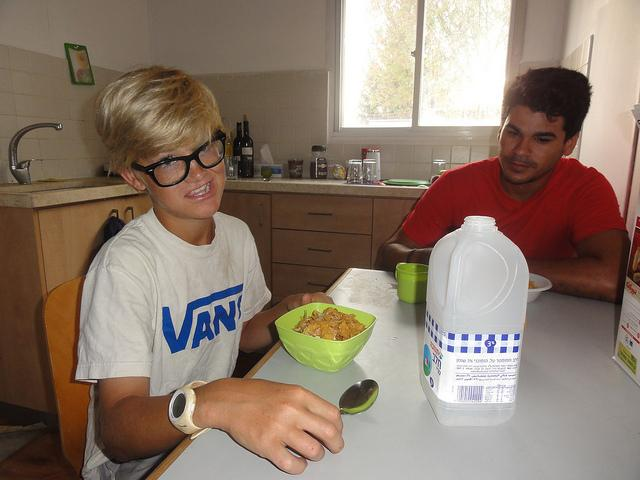What commodity has this young man exhausted?

Choices:
A) oats
B) milk
C) wine
D) none milk 